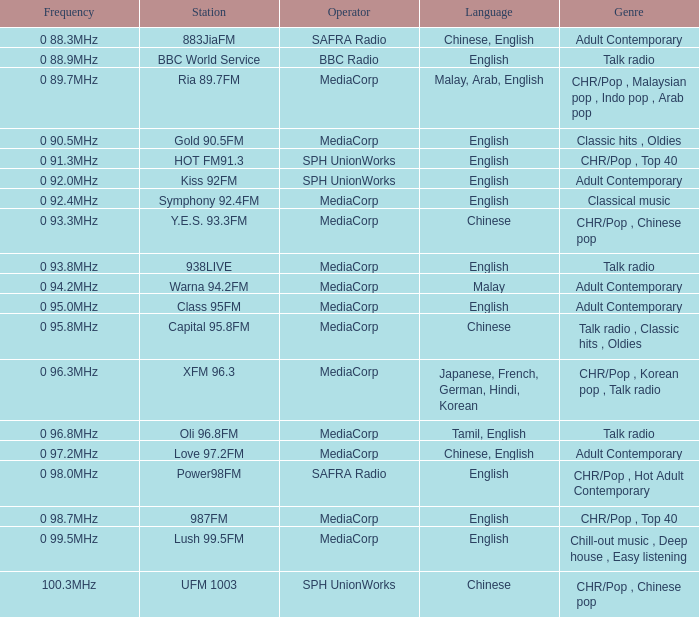Can you parse all the data within this table? {'header': ['Frequency', 'Station', 'Operator', 'Language', 'Genre'], 'rows': [['0 88.3MHz', '883JiaFM', 'SAFRA Radio', 'Chinese, English', 'Adult Contemporary'], ['0 88.9MHz', 'BBC World Service', 'BBC Radio', 'English', 'Talk radio'], ['0 89.7MHz', 'Ria 89.7FM', 'MediaCorp', 'Malay, Arab, English', 'CHR/Pop , Malaysian pop , Indo pop , Arab pop'], ['0 90.5MHz', 'Gold 90.5FM', 'MediaCorp', 'English', 'Classic hits , Oldies'], ['0 91.3MHz', 'HOT FM91.3', 'SPH UnionWorks', 'English', 'CHR/Pop , Top 40'], ['0 92.0MHz', 'Kiss 92FM', 'SPH UnionWorks', 'English', 'Adult Contemporary'], ['0 92.4MHz', 'Symphony 92.4FM', 'MediaCorp', 'English', 'Classical music'], ['0 93.3MHz', 'Y.E.S. 93.3FM', 'MediaCorp', 'Chinese', 'CHR/Pop , Chinese pop'], ['0 93.8MHz', '938LIVE', 'MediaCorp', 'English', 'Talk radio'], ['0 94.2MHz', 'Warna 94.2FM', 'MediaCorp', 'Malay', 'Adult Contemporary'], ['0 95.0MHz', 'Class 95FM', 'MediaCorp', 'English', 'Adult Contemporary'], ['0 95.8MHz', 'Capital 95.8FM', 'MediaCorp', 'Chinese', 'Talk radio , Classic hits , Oldies'], ['0 96.3MHz', 'XFM 96.3', 'MediaCorp', 'Japanese, French, German, Hindi, Korean', 'CHR/Pop , Korean pop , Talk radio'], ['0 96.8MHz', 'Oli 96.8FM', 'MediaCorp', 'Tamil, English', 'Talk radio'], ['0 97.2MHz', 'Love 97.2FM', 'MediaCorp', 'Chinese, English', 'Adult Contemporary'], ['0 98.0MHz', 'Power98FM', 'SAFRA Radio', 'English', 'CHR/Pop , Hot Adult Contemporary'], ['0 98.7MHz', '987FM', 'MediaCorp', 'English', 'CHR/Pop , Top 40'], ['0 99.5MHz', 'Lush 99.5FM', 'MediaCorp', 'English', 'Chill-out music , Deep house , Easy listening'], ['100.3MHz', 'UFM 1003', 'SPH UnionWorks', 'Chinese', 'CHR/Pop , Chinese pop']]} Which station is operated by BBC Radio under the talk radio genre? BBC World Service. 